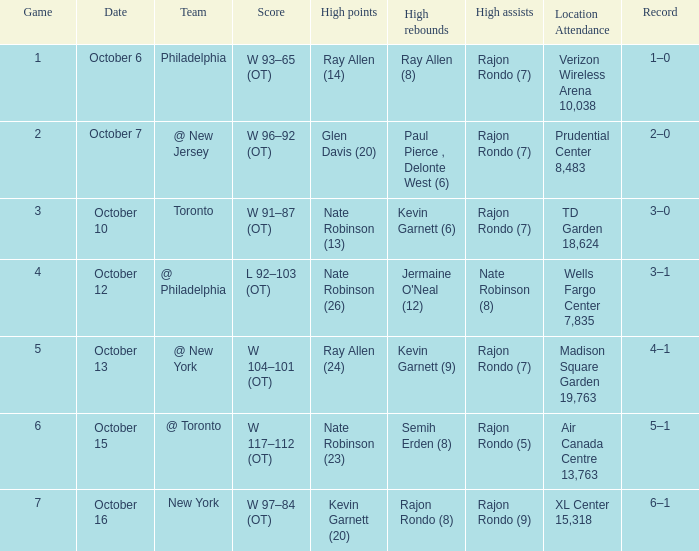Who had the most rebounds and how many did they have on October 16? Rajon Rondo (8). 